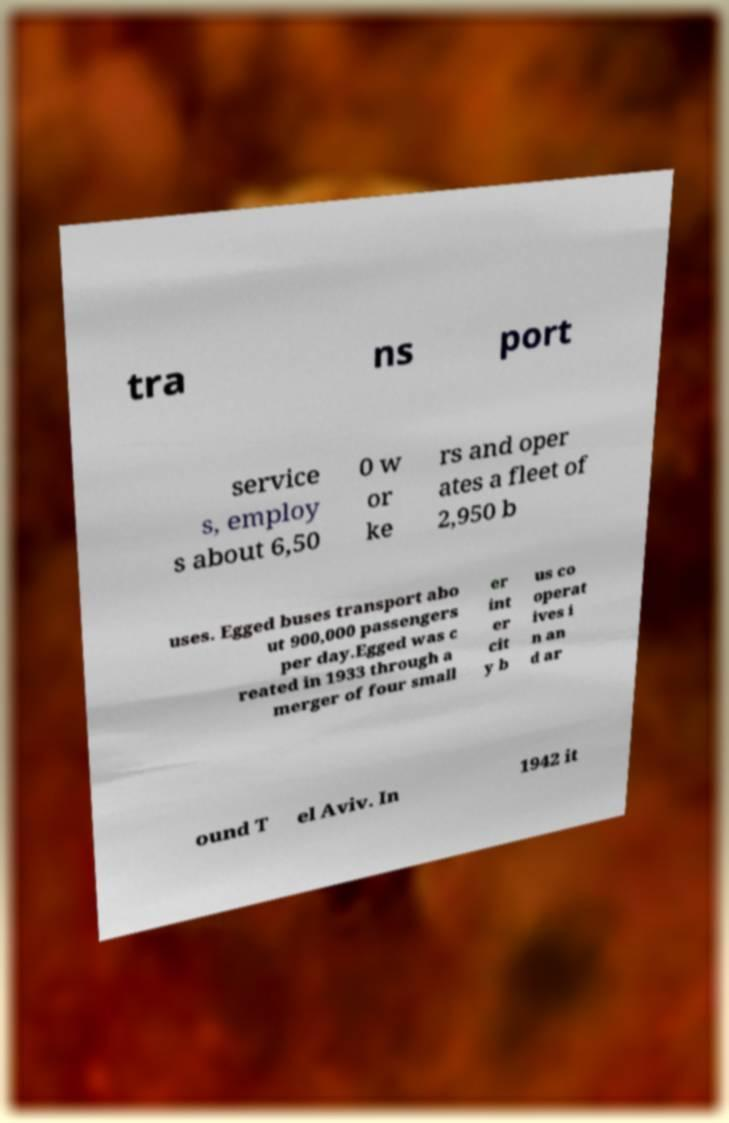Can you read and provide the text displayed in the image?This photo seems to have some interesting text. Can you extract and type it out for me? tra ns port service s, employ s about 6,50 0 w or ke rs and oper ates a fleet of 2,950 b uses. Egged buses transport abo ut 900,000 passengers per day.Egged was c reated in 1933 through a merger of four small er int er cit y b us co operat ives i n an d ar ound T el Aviv. In 1942 it 